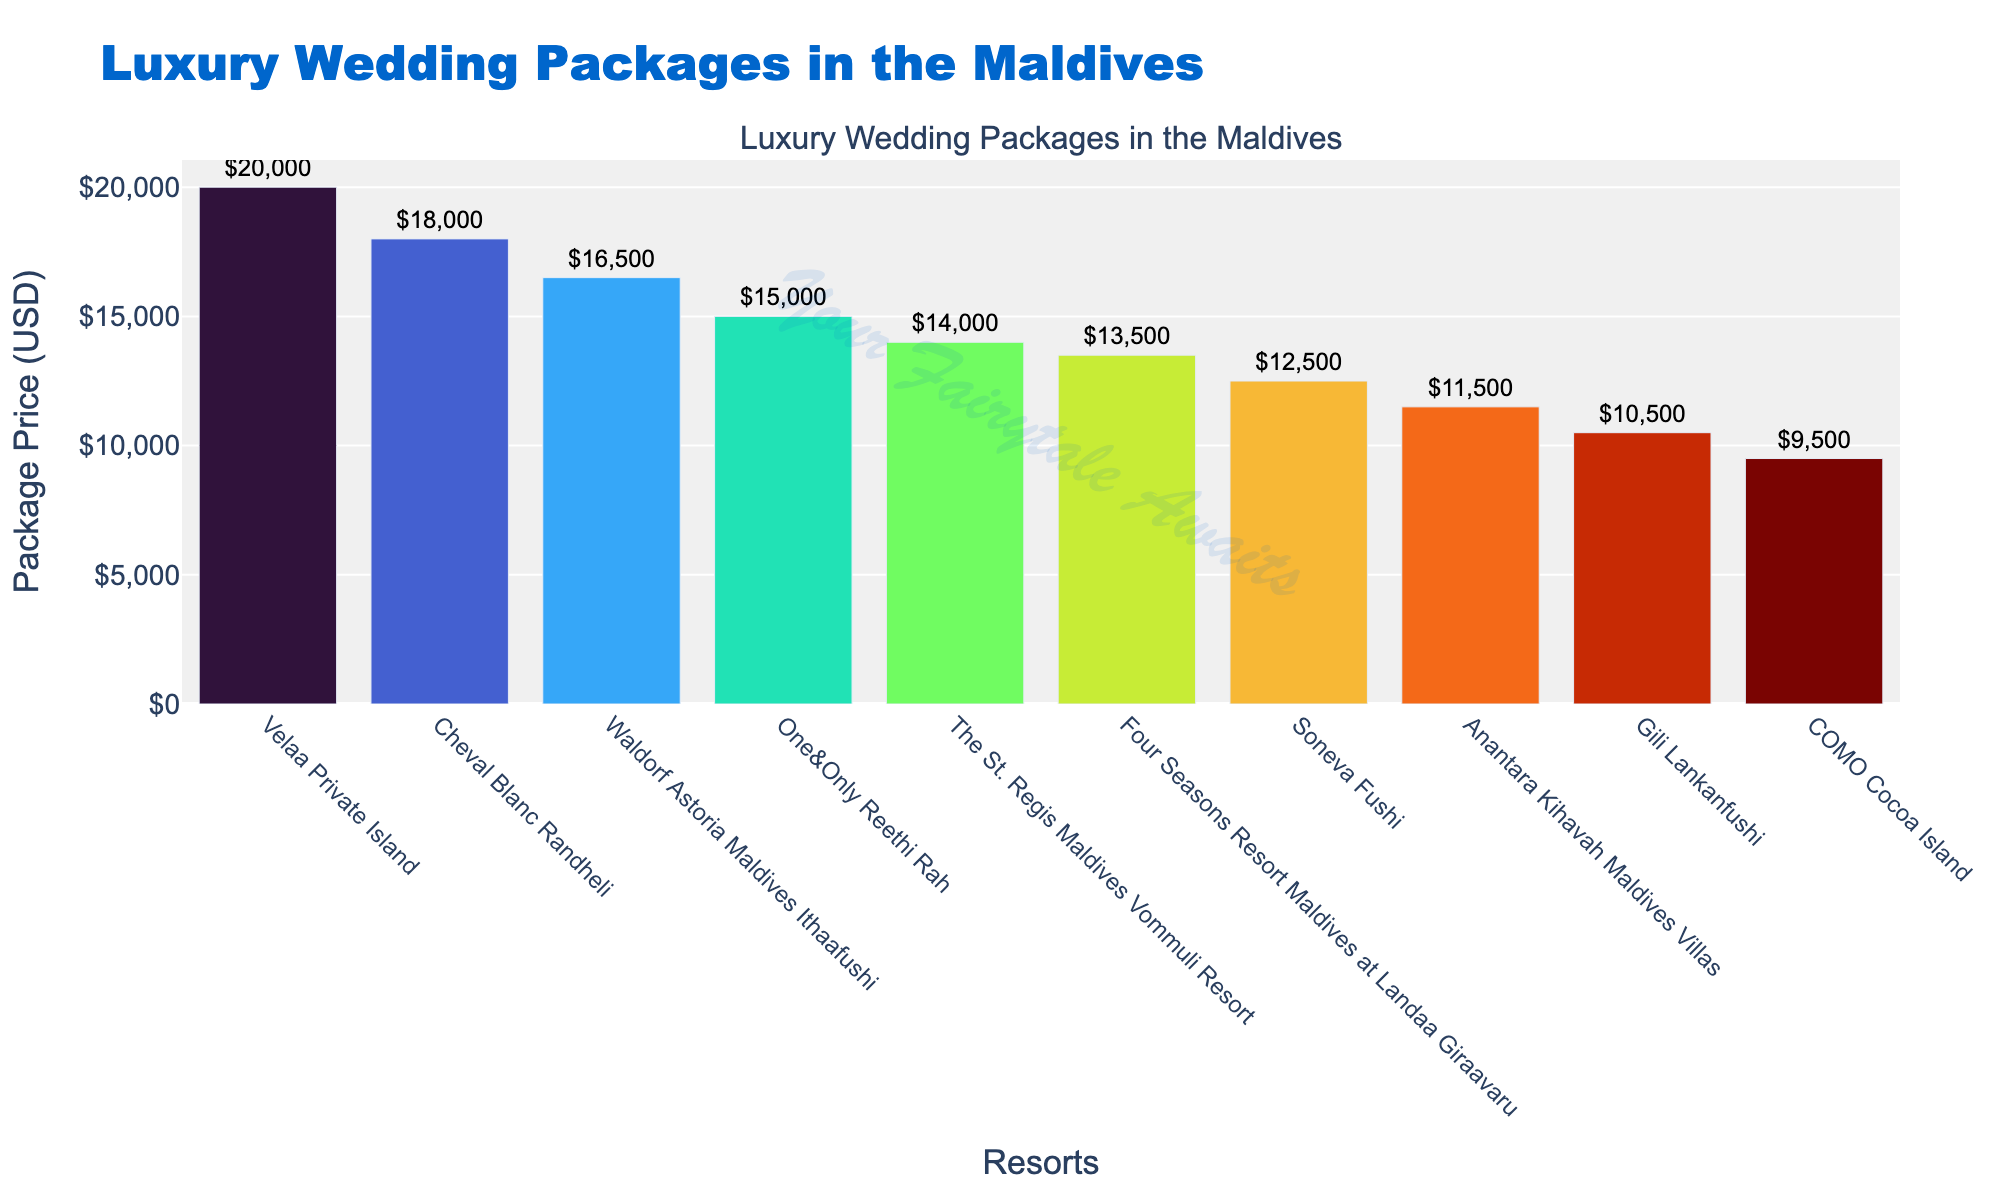What is the most expensive wedding package among the resorts? The figure shows a bar for each resort, and we can identify the tallest bar to determine the most expensive package. The highest bar corresponds to Velaa Private Island, with a package price of $20,000.
Answer: Velaa Private Island Which resort offers the least expensive wedding package? By identifying the shortest bar in the chart, we can determine that COMO Cocoa Island has the least expensive package, with a price of $9,500.
Answer: COMO Cocoa Island How much more expensive is the wedding package at Cheval Blanc Randheli compared to Gili Lankanfushi? Locate the bars for Cheval Blanc Randheli and Gili Lankanfushi. The price difference can be calculated by subtracting Gili Lankanfushi's package price of $10,500 from Cheval Blanc Randheli's $18,000, resulting in a difference of $7,500.
Answer: $7,500 What is the average price of all the wedding packages displayed in the chart? To calculate the average, sum all the package prices and then divide by the total number of packages. Summing the prices: $12,500 + $15,000 + $18,000 + $13,500 + $14,000 + $11,500 + $10,500 + $20,000 + $16,500 + $9,500 = $141,000. Dividing by the number of resorts (10) gives $141,000 / 10 = $14,100.
Answer: $14,100 Which resorts have wedding packages priced below the average price? First, find the average price calculated previously ($14,100). Then, identify the resorts with prices below this value: Soneva Fushi ($12,500), Four Seasons Resort Maldives at Landaa Giraavaru ($13,500), The St. Regis Maldives Vommuli Resort ($14,000), Anantara Kihavah Maldives Villas ($11,500), Gili Lankanfushi ($10,500), and COMO Cocoa Island ($9,500).
Answer: Soneva Fushi, Four Seasons Resort Maldives at Landaa Giraavaru, The St. Regis Maldives Vommuli Resort, Anantara Kihavah Maldives Villas, Gili Lankanfushi, COMO Cocoa Island Which resorts have their package prices within $1,000 of each other, and what are those prices? Look for resorts whose bars nearly align in height within a $1,000 range. Four Seasons Resort Maldives at Landaa Giraavaru ($13,500) and The St. Regis Maldives Vommuli Resort ($14,000) have package prices within $1,000 of each other.
Answer: Four Seasons Resort Maldives at Landaa Giraavaru ($13,500), The St. Regis Maldives Vommuli Resort ($14,000) By how much does the price at One&Only Reethi Rah exceed the price at Soneva Fushi? Find the bars for One&Only Reethi Rah ($15,000) and Soneva Fushi ($12,500). Subtract Soneva Fushi's price from One&Only Reethi Rah's price to get $15,000 - $12,500 = $2,500.
Answer: $2,500 What is the combined cost of the wedding packages at Gili Lankanfushi, Velaa Private Island, and Waldorf Astoria Maldives Ithaafushi? Sum the package prices of Gili Lankanfushi ($10,500), Velaa Private Island ($20,000), and Waldorf Astoria Maldives Ithaafushi ($16,500). The total is $10,500 + $20,000 + $16,500 = $47,000.
Answer: $47,000 